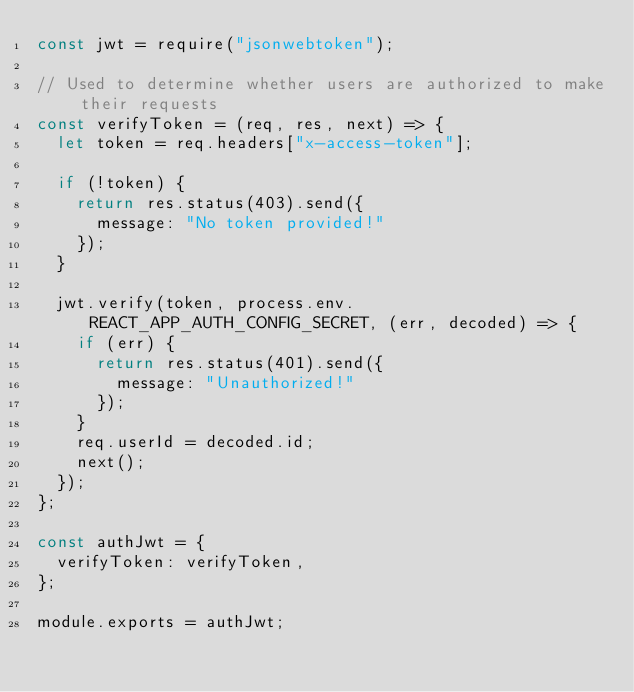<code> <loc_0><loc_0><loc_500><loc_500><_JavaScript_>const jwt = require("jsonwebtoken");

// Used to determine whether users are authorized to make their requests
const verifyToken = (req, res, next) => {
  let token = req.headers["x-access-token"];

  if (!token) {
    return res.status(403).send({
      message: "No token provided!"
    });
  }

  jwt.verify(token, process.env.REACT_APP_AUTH_CONFIG_SECRET, (err, decoded) => {
    if (err) {
      return res.status(401).send({
        message: "Unauthorized!"
      });
    }
    req.userId = decoded.id;
    next();
  });
};

const authJwt = {
  verifyToken: verifyToken,
};

module.exports = authJwt;

</code> 